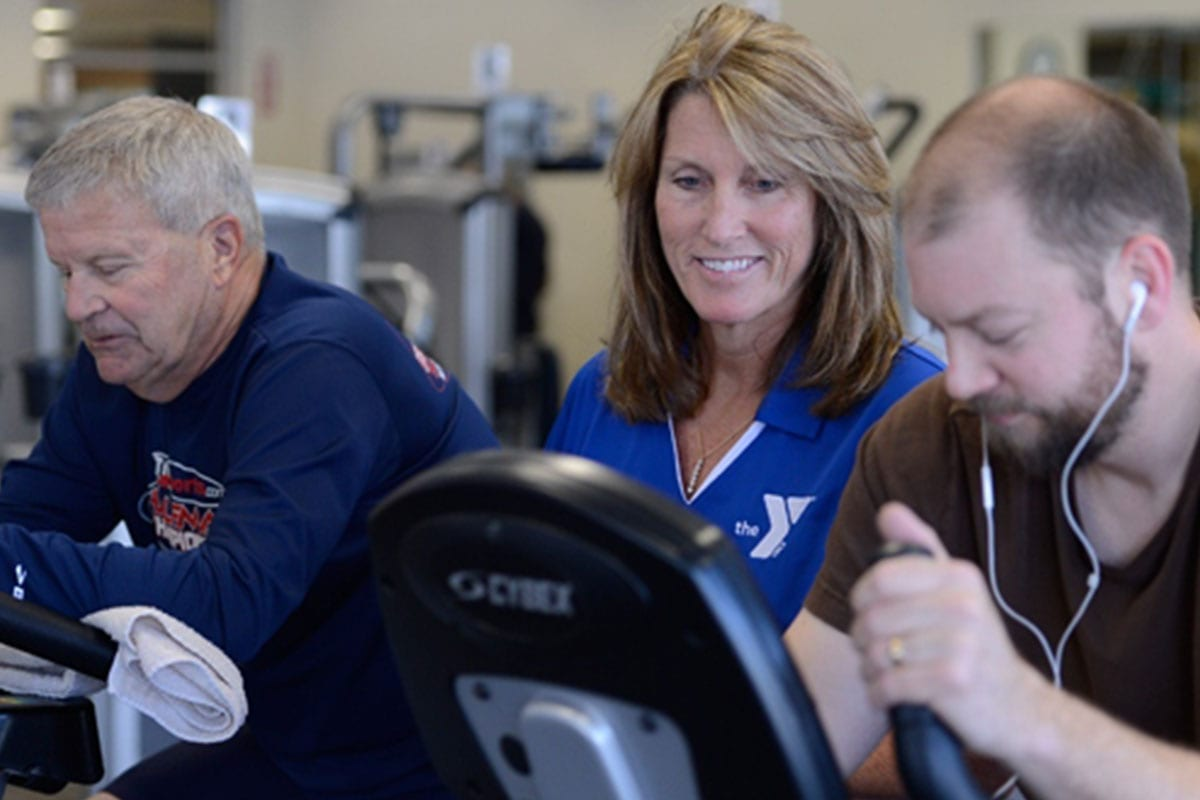How can the instructor adapt the workout for individuals who may have physical limitations or injuries? The instructor can adapt the workout for individuals with physical limitations or injuries by offering modifications and alternative exercises. For example, she might suggest performing the exercise at a lower resistance or slower pace. She could also recommend seated exercises or those that do not put stress on the affected area. Additionally, the instructor could provide guidance on proper stretching and warm-up routines to prevent further injury. Her role would be to closely monitor these individuals, ensuring they are comfortable and safe while still benefiting from the workout. </image> What are the long-term benefits of having an instructor-led exercise program compared to self-guided workouts? An instructor-led exercise program offers several long-term benefits compared to self-guided workouts. Firstly, it ensures that individuals are exercising with correct form and technique, which is crucial in preventing injuries and maximizing effectiveness. Secondly, an instructor can provide structure and variety, keeping the workouts engaging and tailored to individual fitness goals, which helps in maintaining long-term motivation and consistency. Thirdly, the social aspect of group workouts can lead to a supportive community environment, enhancing adherence to the fitness regime. Finally, instructors can offer professional insight and adjustments based on progress, ensuring continuous improvement and adaptation over time.  If the fitness facility decided to implement a reward system based on workout achievements, how could this system work and what kind of rewards would be most effective? A reward system based on workout achievements could include a point-based system where participants earn points for each workout session attended, specific fitness milestones achieved, or participation in fitness challenges. These points could then be redeemed for various rewards such as fitness merchandise, free or discounted classes, personal training sessions, or even entries into prize draws for larger rewards like sports equipment or activity trackers. To keep participants motivated, the system could also include badges or certificates for reaching certain milestones. The most effective rewards would be those that encourage continued participation and engagement, such as items or experiences that further support their fitness journey and health goals. 